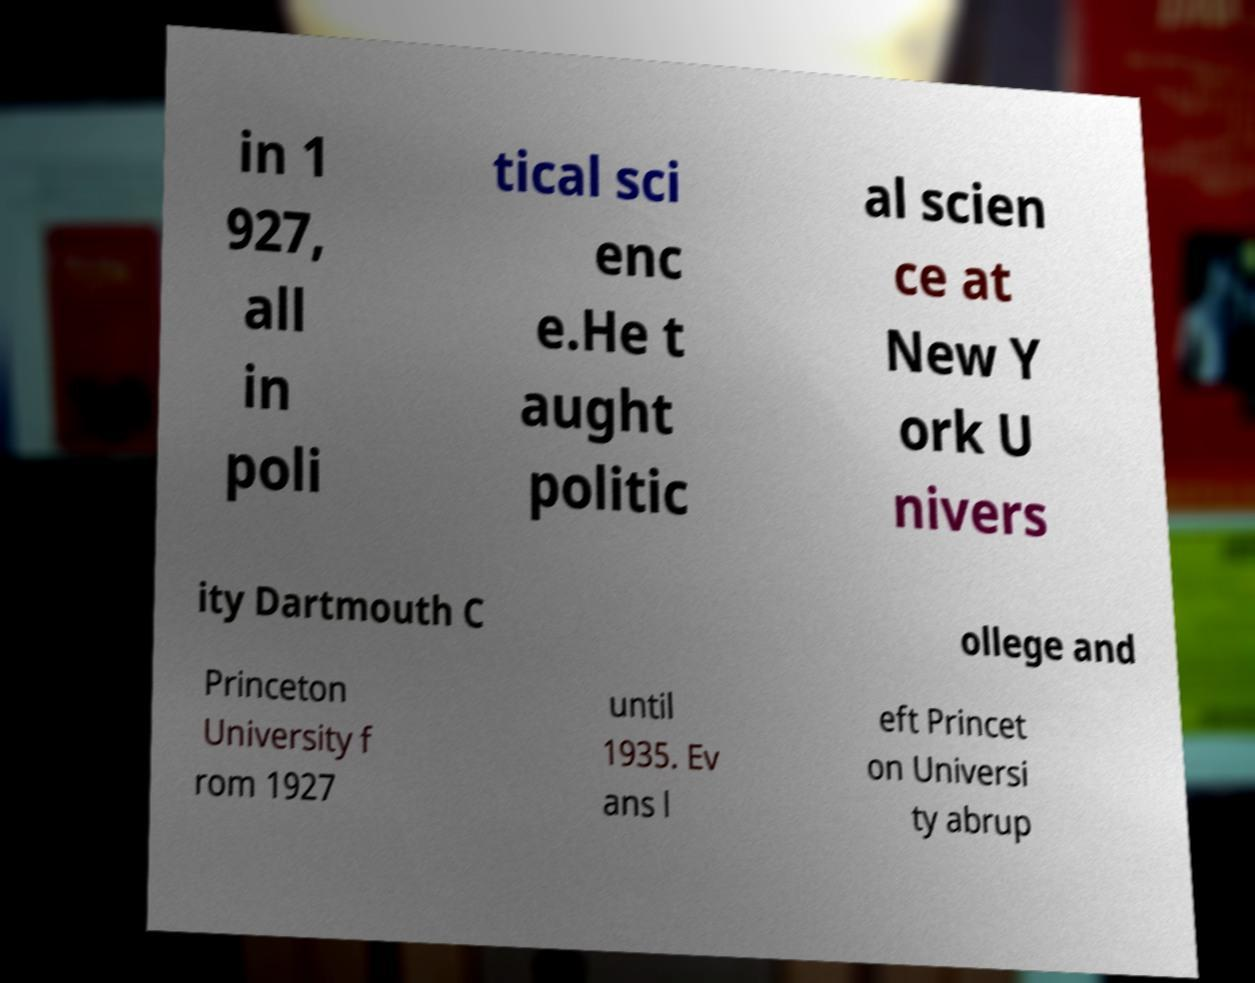Please read and relay the text visible in this image. What does it say? in 1 927, all in poli tical sci enc e.He t aught politic al scien ce at New Y ork U nivers ity Dartmouth C ollege and Princeton University f rom 1927 until 1935. Ev ans l eft Princet on Universi ty abrup 